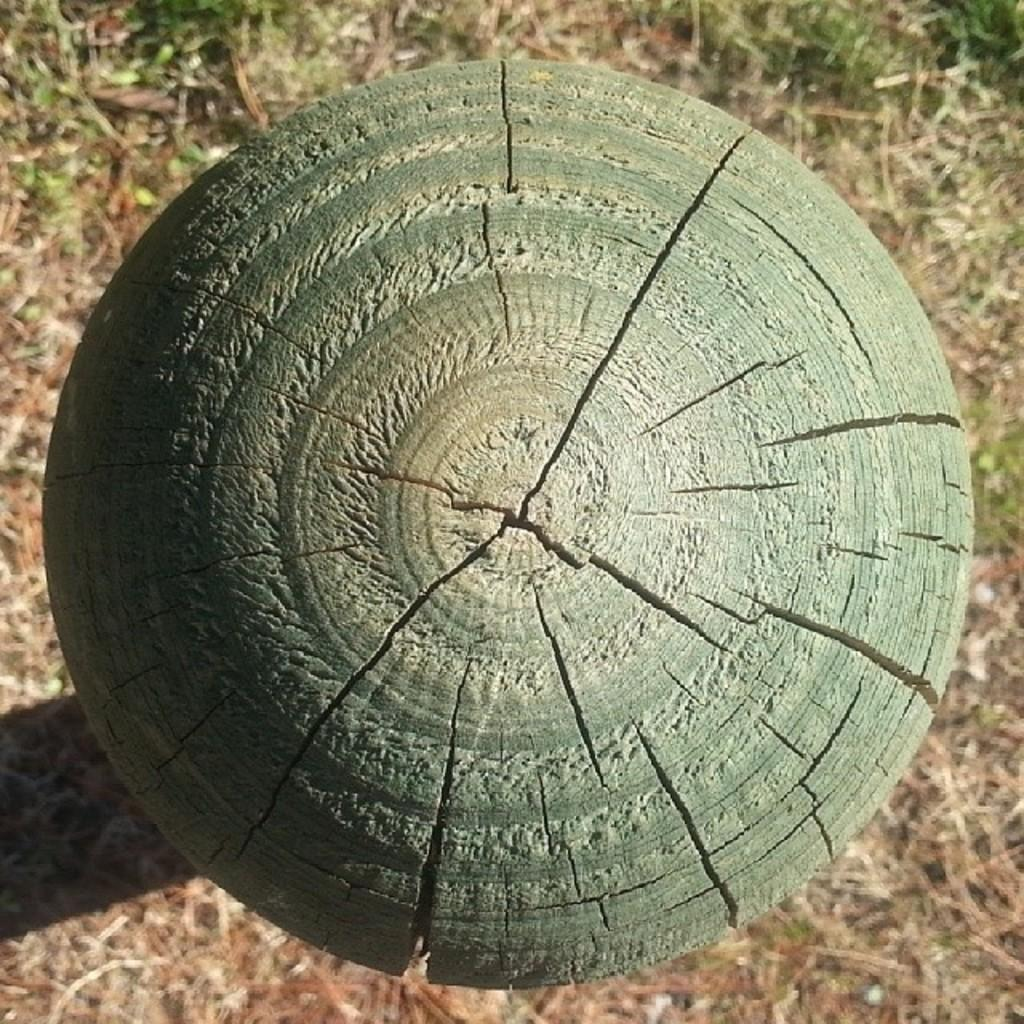What is the shape of the wooden object in the image? The wooden object is round in shape. What color is the wooden object? The wooden object is green in color. What can be seen in the background of the image? There is grass visible in the background of the image. How many cats are sitting on the wooden object in the image? There are no cats present in the image; it only features a round wooden object. What type of comfort does the wooden object provide in the image? The wooden object is not providing any comfort in the image, as it is a stationary object and there are no living beings interacting with it. 